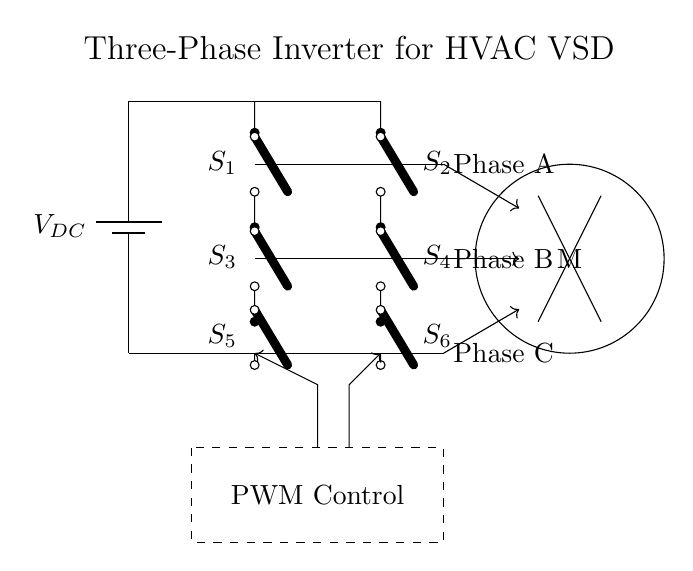What is the voltage source in this circuit? The voltage source is represented as V_DC, indicating the direct current voltage supplied to the inverter.
Answer: V_DC How many switches are there in the inverter? The inverter consists of six switches labeled S1, S2, S3, S4, S5, and S6, which are responsible for controlling the power flow.
Answer: 6 What is the purpose of the PWM Control block? The PWM Control block generates pulse-width modulation signals that determine the switching intervals of the inverter's switches, adjusting output voltage and frequency for motor control.
Answer: Motor control Which component connects to the motor? The output phases A, B, and C are connected to the motor, which converts electrical energy into mechanical energy for HVAC systems.
Answer: Output phases What type of inverter is illustrated in this circuit? The circuit illustrates a three-phase inverter, which is designed to convert DC voltage into three-phase AC voltage suitable for driving variable speed drives.
Answer: Three-phase inverter How many phases are indicated in the output? The output consists of three distinct phases labeled Phase A, Phase B, and Phase C, which are used to create a rotating magnetic field in the motor.
Answer: 3 